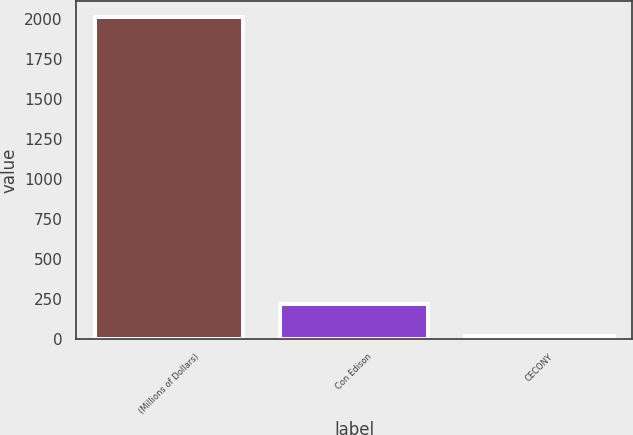Convert chart. <chart><loc_0><loc_0><loc_500><loc_500><bar_chart><fcel>(Millions of Dollars)<fcel>Con Edison<fcel>CECONY<nl><fcel>2012<fcel>218.3<fcel>19<nl></chart> 